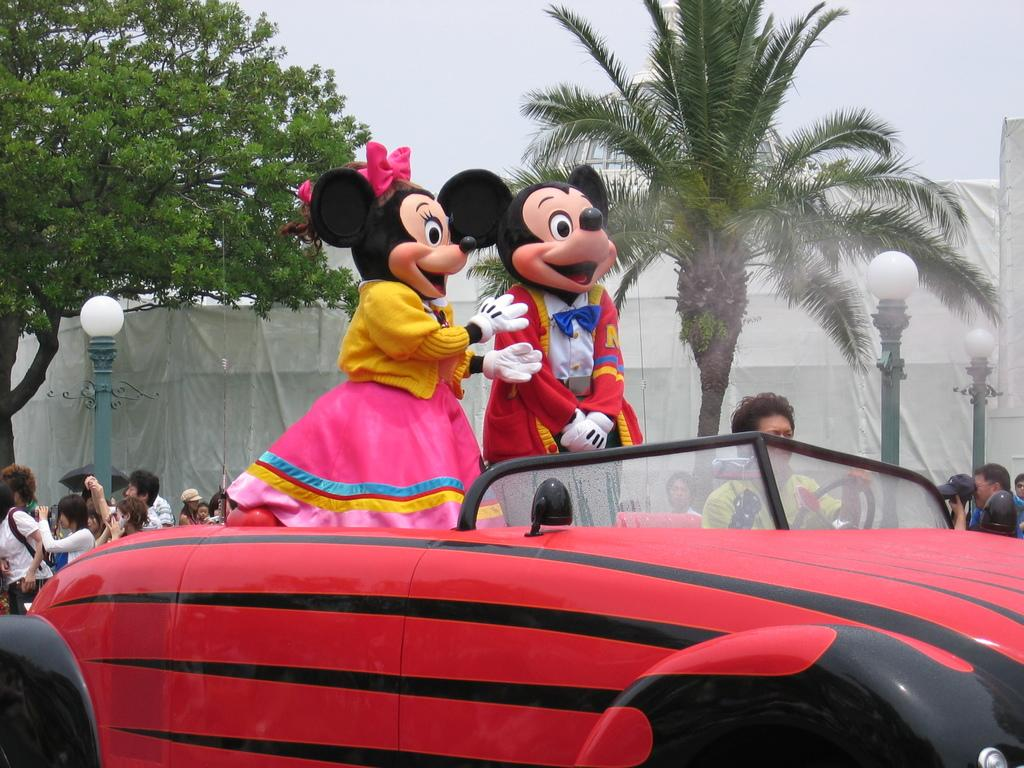What is on the vehicle in the image? There are two Mickey Mouse costumes on a vehicle. What can be seen in the background of the image? There is a group of people, lights, trees, and the sky visible in the background. What type of salt is being used to season the goat in the image? There is no goat or salt present in the image; it features Mickey Mouse costumes on a vehicle and a background with people, lights, trees, and the sky. 